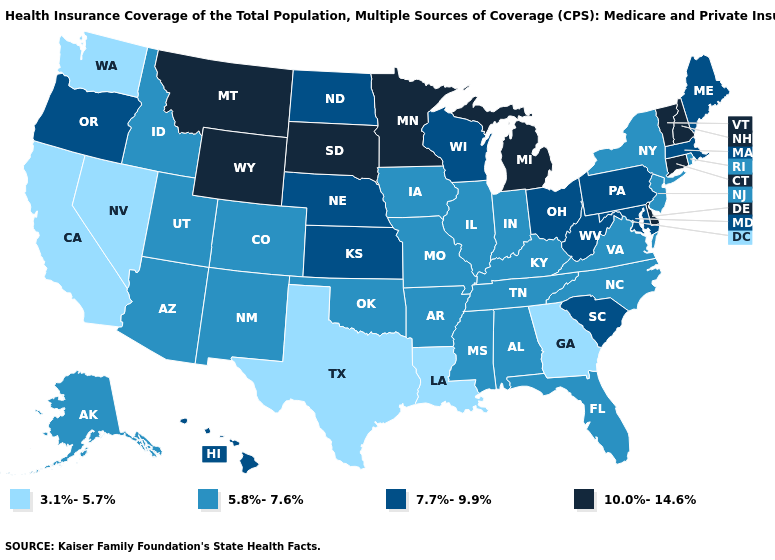Which states have the lowest value in the USA?
Short answer required. California, Georgia, Louisiana, Nevada, Texas, Washington. What is the value of Virginia?
Answer briefly. 5.8%-7.6%. Among the states that border Arizona , which have the highest value?
Write a very short answer. Colorado, New Mexico, Utah. Name the states that have a value in the range 5.8%-7.6%?
Concise answer only. Alabama, Alaska, Arizona, Arkansas, Colorado, Florida, Idaho, Illinois, Indiana, Iowa, Kentucky, Mississippi, Missouri, New Jersey, New Mexico, New York, North Carolina, Oklahoma, Rhode Island, Tennessee, Utah, Virginia. What is the value of Kansas?
Be succinct. 7.7%-9.9%. Name the states that have a value in the range 7.7%-9.9%?
Write a very short answer. Hawaii, Kansas, Maine, Maryland, Massachusetts, Nebraska, North Dakota, Ohio, Oregon, Pennsylvania, South Carolina, West Virginia, Wisconsin. How many symbols are there in the legend?
Write a very short answer. 4. Does the map have missing data?
Short answer required. No. Does the first symbol in the legend represent the smallest category?
Write a very short answer. Yes. Name the states that have a value in the range 3.1%-5.7%?
Give a very brief answer. California, Georgia, Louisiana, Nevada, Texas, Washington. Does Minnesota have the highest value in the USA?
Quick response, please. Yes. Which states have the highest value in the USA?
Answer briefly. Connecticut, Delaware, Michigan, Minnesota, Montana, New Hampshire, South Dakota, Vermont, Wyoming. Does California have the same value as Wyoming?
Answer briefly. No. Does the map have missing data?
Be succinct. No. What is the value of Texas?
Be succinct. 3.1%-5.7%. 